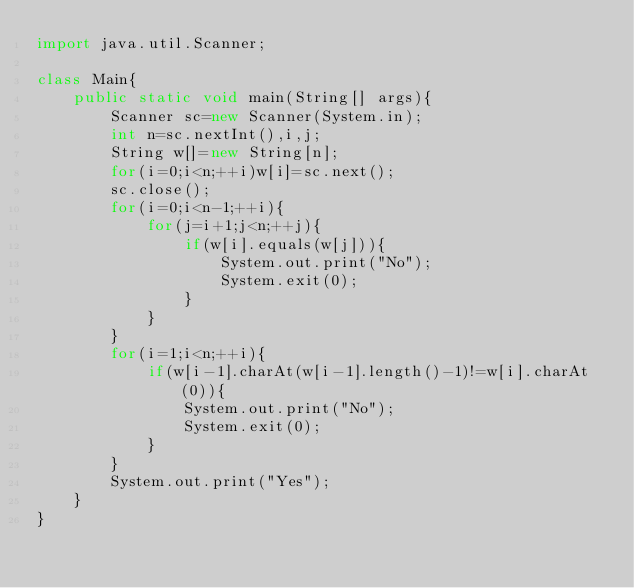Convert code to text. <code><loc_0><loc_0><loc_500><loc_500><_Java_>import java.util.Scanner;

class Main{
    public static void main(String[] args){
        Scanner sc=new Scanner(System.in);
        int n=sc.nextInt(),i,j;
        String w[]=new String[n];
        for(i=0;i<n;++i)w[i]=sc.next();
        sc.close();
        for(i=0;i<n-1;++i){
            for(j=i+1;j<n;++j){
                if(w[i].equals(w[j])){
                    System.out.print("No");
                    System.exit(0);
                }
            }
        }
        for(i=1;i<n;++i){
            if(w[i-1].charAt(w[i-1].length()-1)!=w[i].charAt(0)){
                System.out.print("No");
                System.exit(0);
            }
        }
        System.out.print("Yes");
    }
}</code> 